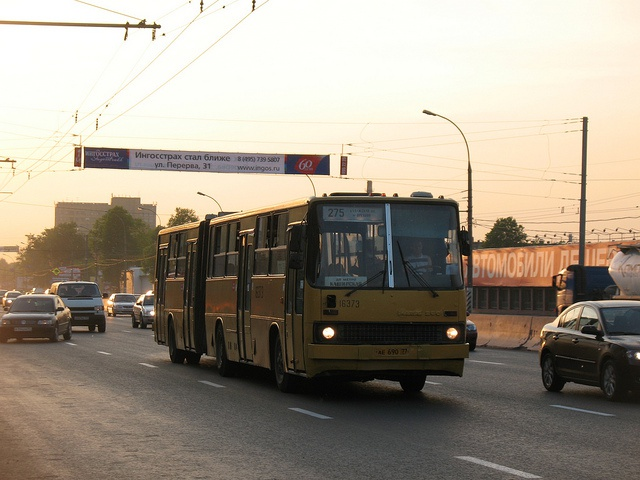Describe the objects in this image and their specific colors. I can see bus in white, black, and gray tones, car in white, black, gray, darkgray, and maroon tones, truck in white, black, gray, and darkgray tones, car in white, gray, maroon, and black tones, and car in white, black, and gray tones in this image. 